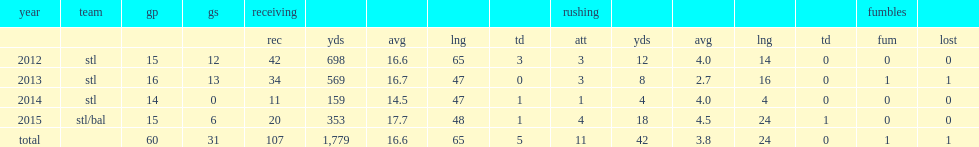How many receiving yards did chris givens get in 2013? 569.0. 